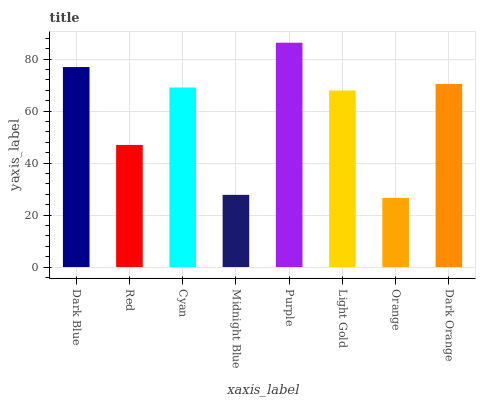Is Red the minimum?
Answer yes or no. No. Is Red the maximum?
Answer yes or no. No. Is Dark Blue greater than Red?
Answer yes or no. Yes. Is Red less than Dark Blue?
Answer yes or no. Yes. Is Red greater than Dark Blue?
Answer yes or no. No. Is Dark Blue less than Red?
Answer yes or no. No. Is Cyan the high median?
Answer yes or no. Yes. Is Light Gold the low median?
Answer yes or no. Yes. Is Purple the high median?
Answer yes or no. No. Is Cyan the low median?
Answer yes or no. No. 